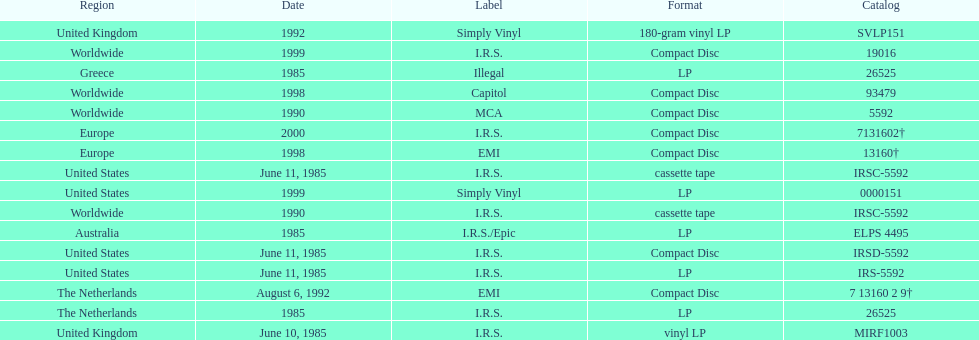How many times was the album released? 13. 